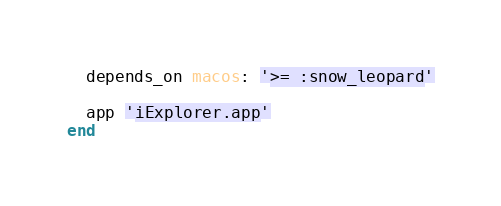Convert code to text. <code><loc_0><loc_0><loc_500><loc_500><_Ruby_>
  depends_on macos: '>= :snow_leopard'

  app 'iExplorer.app'
end
</code> 